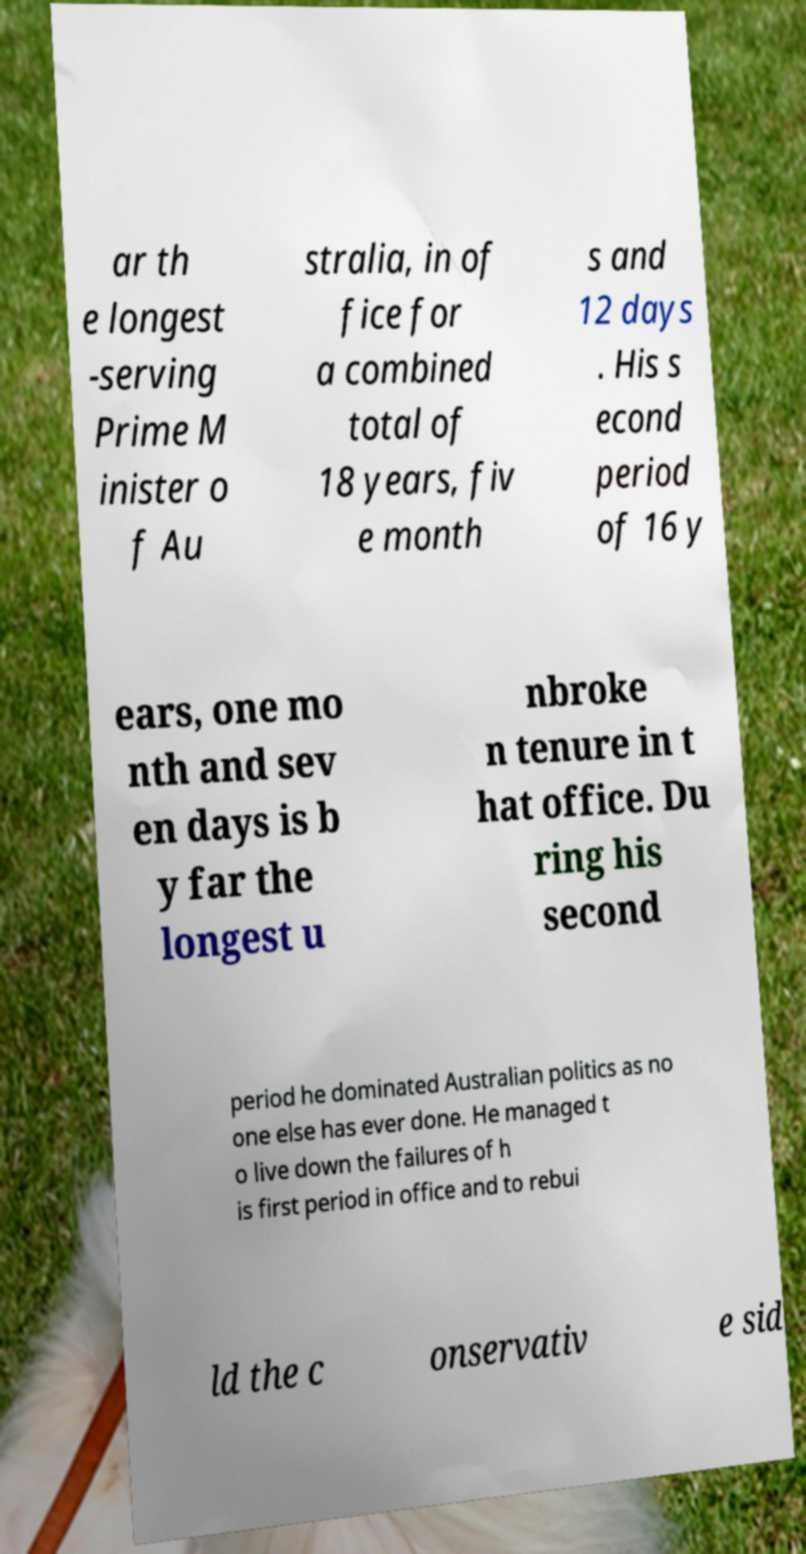Could you assist in decoding the text presented in this image and type it out clearly? ar th e longest -serving Prime M inister o f Au stralia, in of fice for a combined total of 18 years, fiv e month s and 12 days . His s econd period of 16 y ears, one mo nth and sev en days is b y far the longest u nbroke n tenure in t hat office. Du ring his second period he dominated Australian politics as no one else has ever done. He managed t o live down the failures of h is first period in office and to rebui ld the c onservativ e sid 